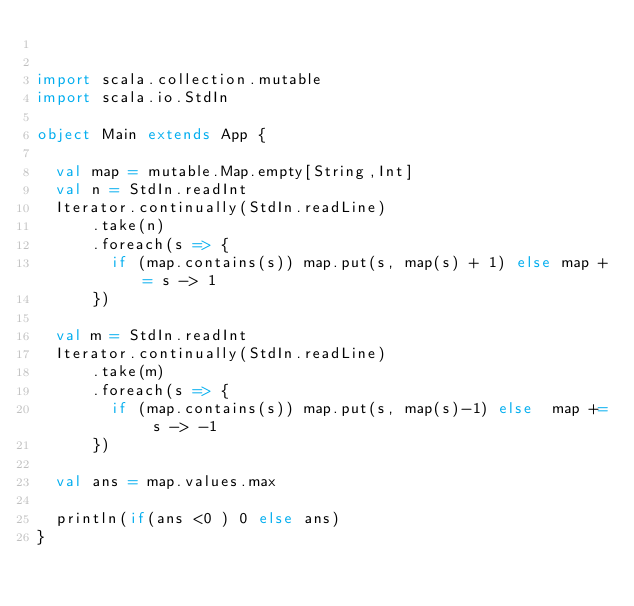Convert code to text. <code><loc_0><loc_0><loc_500><loc_500><_Scala_>

import scala.collection.mutable
import scala.io.StdIn

object Main extends App {

  val map = mutable.Map.empty[String,Int]
  val n = StdIn.readInt
  Iterator.continually(StdIn.readLine)
      .take(n)
      .foreach(s => {
        if (map.contains(s)) map.put(s, map(s) + 1) else map += s -> 1
      })

  val m = StdIn.readInt
  Iterator.continually(StdIn.readLine)
      .take(m)
      .foreach(s => {
        if (map.contains(s)) map.put(s, map(s)-1) else  map += s -> -1
      })

  val ans = map.values.max

  println(if(ans <0 ) 0 else ans)
}</code> 